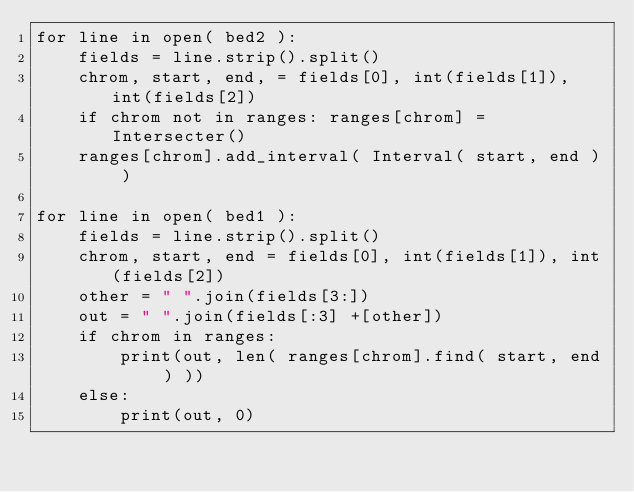Convert code to text. <code><loc_0><loc_0><loc_500><loc_500><_Python_>for line in open( bed2 ):
    fields = line.strip().split() 
    chrom, start, end, = fields[0], int(fields[1]), int(fields[2])
    if chrom not in ranges: ranges[chrom] = Intersecter()
    ranges[chrom].add_interval( Interval( start, end ) )
    
for line in open( bed1 ):
    fields = line.strip().split() 
    chrom, start, end = fields[0], int(fields[1]), int(fields[2]) 
    other = " ".join(fields[3:])
    out = " ".join(fields[:3] +[other])
    if chrom in ranges: 
        print(out, len( ranges[chrom].find( start, end ) ))
    else:
        print(out, 0)

</code> 